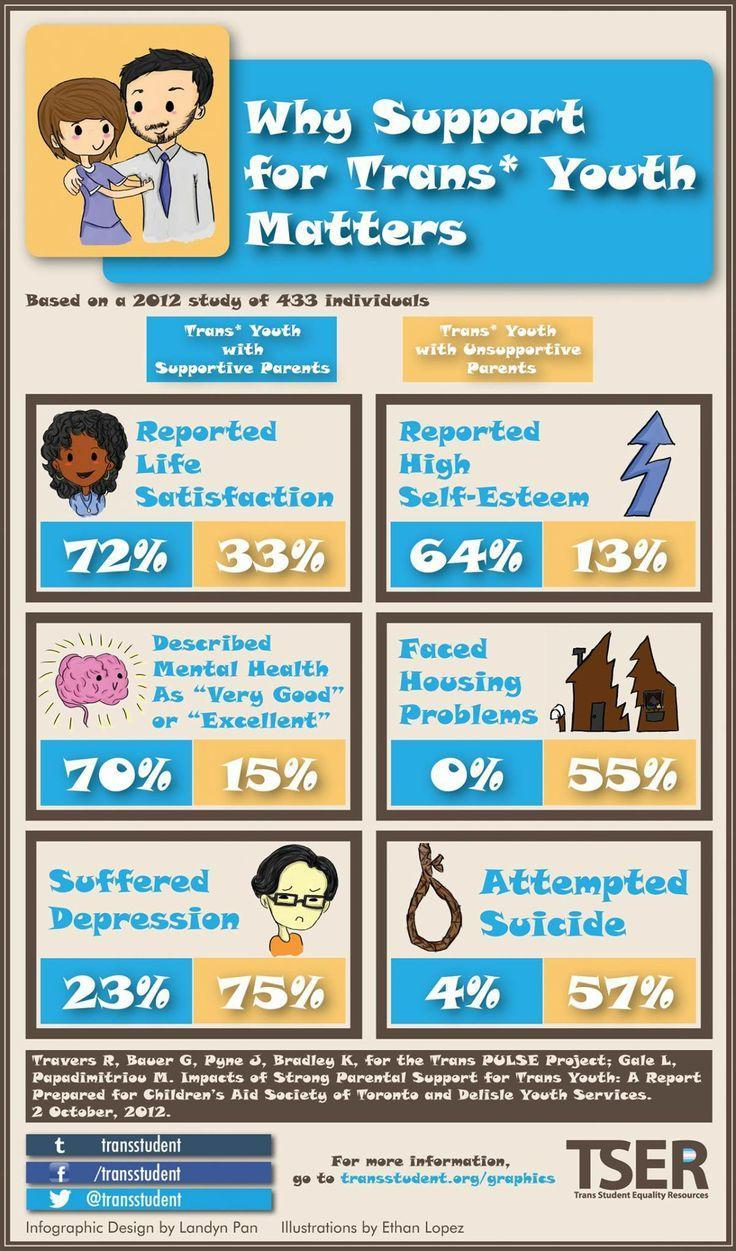What percentage of trans youth reported satisfaction with unsupported parents?
Answer the question with a short phrase. 33% What percentage of trans youth with unsupported parents faced Housing problems? 55% What percentage of trans youth did not report self satisfaction with supportive parents? 28 What percentage of trans youth with supportive parents faced Housing problems? 0% What percentage of trans youth with unsupported parents have not attempted suicide? 43 What percentage of trans youth with supportive parents attempted suicide? 4% What percentage of trans youth with supportive parents did not go through depression? 77 What percentage of trans youth with unsupported parents did not report self esteem? 87 What percentage of trans youth reported self esteem are with supportive parents? 64% 